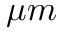Convert formula to latex. <formula><loc_0><loc_0><loc_500><loc_500>\mu m</formula> 